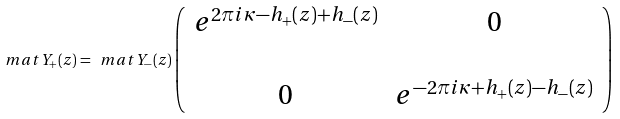Convert formula to latex. <formula><loc_0><loc_0><loc_500><loc_500>\ m a t { Y } _ { + } ( z ) = \ m a t { Y } _ { - } ( z ) \left ( \begin{array} { c c } e ^ { 2 \pi i \kappa - h _ { + } ( z ) + h _ { - } ( z ) } & 0 \\ \\ 0 & e ^ { - 2 \pi i \kappa + h _ { + } ( z ) - h _ { - } ( z ) } \end{array} \right )</formula> 